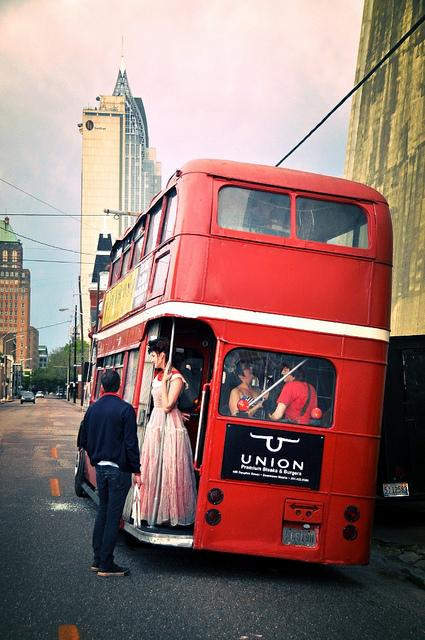What is the purpose of the wires above the vehicle? Please explain your reasoning. power source. The wires in this image are power lines. these wires are used as a power source. 